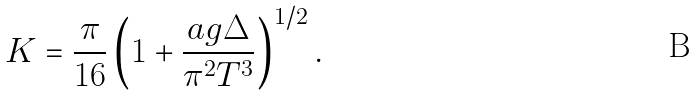Convert formula to latex. <formula><loc_0><loc_0><loc_500><loc_500>K = \frac { \pi } { 1 6 } \left ( 1 + \frac { a g \Delta } { \pi ^ { 2 } T ^ { 3 } } \right ) ^ { 1 / 2 } .</formula> 